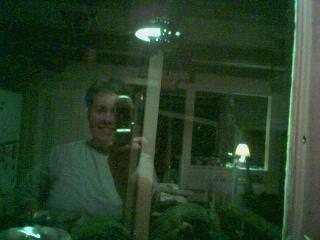How many cats there?
Give a very brief answer. 0. 